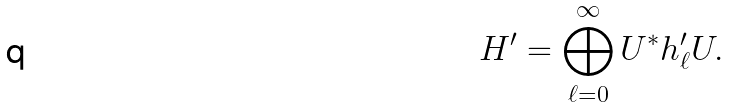<formula> <loc_0><loc_0><loc_500><loc_500>H ^ { \prime } = \bigoplus _ { \ell = 0 } ^ { \infty } U ^ { * } h ^ { \prime } _ { \ell } U .</formula> 